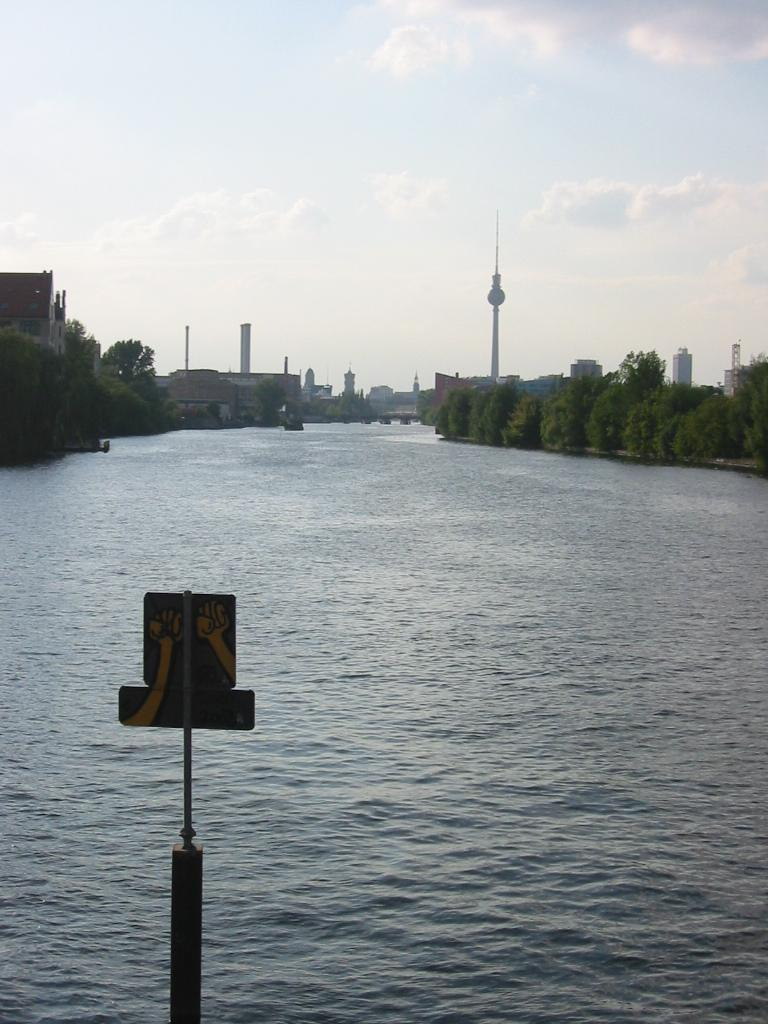What is attached to the pole in the image? There is a board attached to a pole in the image. What can be seen in the foreground of the image? Water is visible in the image. What type of vegetation is present in the image? There are trees in the image. What type of structures can be seen in the image? Tower buildings are present in the image. What is visible in the background of the image? The sky is visible in the background of the image. What can be observed in the sky? Clouds are present in the sky. What color are the jeans worn by the tree in the image? There are no jeans or trees wearing jeans present in the image. How many twigs are attached to the tower buildings in the image? There are no twigs attached to the tower buildings in the image. 